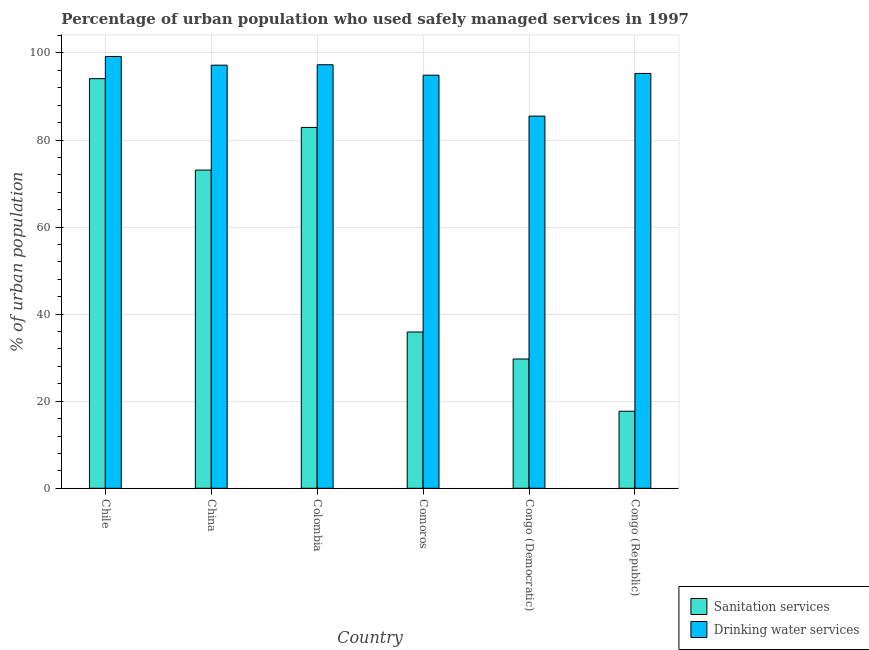How many groups of bars are there?
Offer a terse response. 6. Are the number of bars on each tick of the X-axis equal?
Give a very brief answer. Yes. What is the label of the 5th group of bars from the left?
Give a very brief answer. Congo (Democratic). In how many cases, is the number of bars for a given country not equal to the number of legend labels?
Your response must be concise. 0. What is the percentage of urban population who used drinking water services in Comoros?
Your answer should be very brief. 94.9. Across all countries, what is the maximum percentage of urban population who used drinking water services?
Your answer should be compact. 99.2. Across all countries, what is the minimum percentage of urban population who used drinking water services?
Provide a short and direct response. 85.5. In which country was the percentage of urban population who used sanitation services minimum?
Keep it short and to the point. Congo (Republic). What is the total percentage of urban population who used sanitation services in the graph?
Offer a terse response. 333.4. What is the difference between the percentage of urban population who used drinking water services in China and that in Comoros?
Give a very brief answer. 2.3. What is the difference between the percentage of urban population who used sanitation services in China and the percentage of urban population who used drinking water services in Chile?
Offer a very short reply. -26.1. What is the average percentage of urban population who used drinking water services per country?
Provide a succinct answer. 94.9. What is the difference between the percentage of urban population who used drinking water services and percentage of urban population who used sanitation services in Comoros?
Your answer should be very brief. 59. In how many countries, is the percentage of urban population who used sanitation services greater than 80 %?
Your response must be concise. 2. What is the ratio of the percentage of urban population who used sanitation services in Colombia to that in Congo (Republic)?
Offer a terse response. 4.68. Is the percentage of urban population who used drinking water services in Colombia less than that in Comoros?
Your response must be concise. No. What is the difference between the highest and the second highest percentage of urban population who used sanitation services?
Your answer should be compact. 11.2. What is the difference between the highest and the lowest percentage of urban population who used drinking water services?
Ensure brevity in your answer.  13.7. What does the 2nd bar from the left in Comoros represents?
Your response must be concise. Drinking water services. What does the 1st bar from the right in Comoros represents?
Offer a very short reply. Drinking water services. How many countries are there in the graph?
Your answer should be very brief. 6. What is the difference between two consecutive major ticks on the Y-axis?
Offer a terse response. 20. Are the values on the major ticks of Y-axis written in scientific E-notation?
Provide a succinct answer. No. How many legend labels are there?
Ensure brevity in your answer.  2. How are the legend labels stacked?
Ensure brevity in your answer.  Vertical. What is the title of the graph?
Your response must be concise. Percentage of urban population who used safely managed services in 1997. Does "Electricity and heat production" appear as one of the legend labels in the graph?
Keep it short and to the point. No. What is the label or title of the Y-axis?
Keep it short and to the point. % of urban population. What is the % of urban population in Sanitation services in Chile?
Your response must be concise. 94.1. What is the % of urban population in Drinking water services in Chile?
Your answer should be compact. 99.2. What is the % of urban population in Sanitation services in China?
Offer a very short reply. 73.1. What is the % of urban population of Drinking water services in China?
Your answer should be compact. 97.2. What is the % of urban population in Sanitation services in Colombia?
Keep it short and to the point. 82.9. What is the % of urban population of Drinking water services in Colombia?
Offer a very short reply. 97.3. What is the % of urban population of Sanitation services in Comoros?
Ensure brevity in your answer.  35.9. What is the % of urban population in Drinking water services in Comoros?
Offer a terse response. 94.9. What is the % of urban population of Sanitation services in Congo (Democratic)?
Ensure brevity in your answer.  29.7. What is the % of urban population in Drinking water services in Congo (Democratic)?
Offer a very short reply. 85.5. What is the % of urban population of Sanitation services in Congo (Republic)?
Offer a terse response. 17.7. What is the % of urban population in Drinking water services in Congo (Republic)?
Offer a very short reply. 95.3. Across all countries, what is the maximum % of urban population of Sanitation services?
Ensure brevity in your answer.  94.1. Across all countries, what is the maximum % of urban population in Drinking water services?
Give a very brief answer. 99.2. Across all countries, what is the minimum % of urban population of Sanitation services?
Keep it short and to the point. 17.7. Across all countries, what is the minimum % of urban population of Drinking water services?
Make the answer very short. 85.5. What is the total % of urban population in Sanitation services in the graph?
Give a very brief answer. 333.4. What is the total % of urban population of Drinking water services in the graph?
Provide a short and direct response. 569.4. What is the difference between the % of urban population in Sanitation services in Chile and that in China?
Offer a terse response. 21. What is the difference between the % of urban population in Drinking water services in Chile and that in China?
Ensure brevity in your answer.  2. What is the difference between the % of urban population in Sanitation services in Chile and that in Comoros?
Ensure brevity in your answer.  58.2. What is the difference between the % of urban population of Drinking water services in Chile and that in Comoros?
Your answer should be very brief. 4.3. What is the difference between the % of urban population of Sanitation services in Chile and that in Congo (Democratic)?
Give a very brief answer. 64.4. What is the difference between the % of urban population of Sanitation services in Chile and that in Congo (Republic)?
Give a very brief answer. 76.4. What is the difference between the % of urban population of Drinking water services in China and that in Colombia?
Your response must be concise. -0.1. What is the difference between the % of urban population of Sanitation services in China and that in Comoros?
Ensure brevity in your answer.  37.2. What is the difference between the % of urban population in Sanitation services in China and that in Congo (Democratic)?
Your answer should be compact. 43.4. What is the difference between the % of urban population in Drinking water services in China and that in Congo (Democratic)?
Your answer should be very brief. 11.7. What is the difference between the % of urban population in Sanitation services in China and that in Congo (Republic)?
Make the answer very short. 55.4. What is the difference between the % of urban population in Sanitation services in Colombia and that in Congo (Democratic)?
Your answer should be compact. 53.2. What is the difference between the % of urban population in Drinking water services in Colombia and that in Congo (Democratic)?
Provide a short and direct response. 11.8. What is the difference between the % of urban population in Sanitation services in Colombia and that in Congo (Republic)?
Offer a very short reply. 65.2. What is the difference between the % of urban population in Drinking water services in Colombia and that in Congo (Republic)?
Provide a short and direct response. 2. What is the difference between the % of urban population of Sanitation services in Comoros and that in Congo (Democratic)?
Your answer should be compact. 6.2. What is the difference between the % of urban population in Drinking water services in Comoros and that in Congo (Democratic)?
Offer a very short reply. 9.4. What is the difference between the % of urban population in Drinking water services in Comoros and that in Congo (Republic)?
Provide a succinct answer. -0.4. What is the difference between the % of urban population of Sanitation services in Chile and the % of urban population of Drinking water services in Comoros?
Provide a short and direct response. -0.8. What is the difference between the % of urban population in Sanitation services in Chile and the % of urban population in Drinking water services in Congo (Democratic)?
Provide a succinct answer. 8.6. What is the difference between the % of urban population in Sanitation services in Chile and the % of urban population in Drinking water services in Congo (Republic)?
Keep it short and to the point. -1.2. What is the difference between the % of urban population in Sanitation services in China and the % of urban population in Drinking water services in Colombia?
Provide a succinct answer. -24.2. What is the difference between the % of urban population of Sanitation services in China and the % of urban population of Drinking water services in Comoros?
Offer a very short reply. -21.8. What is the difference between the % of urban population of Sanitation services in China and the % of urban population of Drinking water services in Congo (Democratic)?
Your answer should be compact. -12.4. What is the difference between the % of urban population of Sanitation services in China and the % of urban population of Drinking water services in Congo (Republic)?
Give a very brief answer. -22.2. What is the difference between the % of urban population in Sanitation services in Colombia and the % of urban population in Drinking water services in Comoros?
Provide a succinct answer. -12. What is the difference between the % of urban population in Sanitation services in Colombia and the % of urban population in Drinking water services in Congo (Democratic)?
Ensure brevity in your answer.  -2.6. What is the difference between the % of urban population of Sanitation services in Comoros and the % of urban population of Drinking water services in Congo (Democratic)?
Give a very brief answer. -49.6. What is the difference between the % of urban population of Sanitation services in Comoros and the % of urban population of Drinking water services in Congo (Republic)?
Offer a terse response. -59.4. What is the difference between the % of urban population of Sanitation services in Congo (Democratic) and the % of urban population of Drinking water services in Congo (Republic)?
Keep it short and to the point. -65.6. What is the average % of urban population of Sanitation services per country?
Your response must be concise. 55.57. What is the average % of urban population of Drinking water services per country?
Your response must be concise. 94.9. What is the difference between the % of urban population of Sanitation services and % of urban population of Drinking water services in Chile?
Offer a terse response. -5.1. What is the difference between the % of urban population in Sanitation services and % of urban population in Drinking water services in China?
Offer a terse response. -24.1. What is the difference between the % of urban population in Sanitation services and % of urban population in Drinking water services in Colombia?
Provide a succinct answer. -14.4. What is the difference between the % of urban population of Sanitation services and % of urban population of Drinking water services in Comoros?
Offer a terse response. -59. What is the difference between the % of urban population in Sanitation services and % of urban population in Drinking water services in Congo (Democratic)?
Your response must be concise. -55.8. What is the difference between the % of urban population in Sanitation services and % of urban population in Drinking water services in Congo (Republic)?
Offer a terse response. -77.6. What is the ratio of the % of urban population in Sanitation services in Chile to that in China?
Your response must be concise. 1.29. What is the ratio of the % of urban population of Drinking water services in Chile to that in China?
Provide a succinct answer. 1.02. What is the ratio of the % of urban population of Sanitation services in Chile to that in Colombia?
Offer a terse response. 1.14. What is the ratio of the % of urban population of Drinking water services in Chile to that in Colombia?
Offer a very short reply. 1.02. What is the ratio of the % of urban population of Sanitation services in Chile to that in Comoros?
Provide a short and direct response. 2.62. What is the ratio of the % of urban population of Drinking water services in Chile to that in Comoros?
Offer a terse response. 1.05. What is the ratio of the % of urban population in Sanitation services in Chile to that in Congo (Democratic)?
Give a very brief answer. 3.17. What is the ratio of the % of urban population of Drinking water services in Chile to that in Congo (Democratic)?
Your answer should be very brief. 1.16. What is the ratio of the % of urban population in Sanitation services in Chile to that in Congo (Republic)?
Your response must be concise. 5.32. What is the ratio of the % of urban population of Drinking water services in Chile to that in Congo (Republic)?
Keep it short and to the point. 1.04. What is the ratio of the % of urban population of Sanitation services in China to that in Colombia?
Offer a very short reply. 0.88. What is the ratio of the % of urban population of Drinking water services in China to that in Colombia?
Your response must be concise. 1. What is the ratio of the % of urban population in Sanitation services in China to that in Comoros?
Your answer should be very brief. 2.04. What is the ratio of the % of urban population of Drinking water services in China to that in Comoros?
Give a very brief answer. 1.02. What is the ratio of the % of urban population of Sanitation services in China to that in Congo (Democratic)?
Provide a short and direct response. 2.46. What is the ratio of the % of urban population of Drinking water services in China to that in Congo (Democratic)?
Offer a terse response. 1.14. What is the ratio of the % of urban population of Sanitation services in China to that in Congo (Republic)?
Provide a succinct answer. 4.13. What is the ratio of the % of urban population of Drinking water services in China to that in Congo (Republic)?
Keep it short and to the point. 1.02. What is the ratio of the % of urban population of Sanitation services in Colombia to that in Comoros?
Make the answer very short. 2.31. What is the ratio of the % of urban population of Drinking water services in Colombia to that in Comoros?
Keep it short and to the point. 1.03. What is the ratio of the % of urban population in Sanitation services in Colombia to that in Congo (Democratic)?
Your answer should be compact. 2.79. What is the ratio of the % of urban population in Drinking water services in Colombia to that in Congo (Democratic)?
Make the answer very short. 1.14. What is the ratio of the % of urban population in Sanitation services in Colombia to that in Congo (Republic)?
Make the answer very short. 4.68. What is the ratio of the % of urban population in Drinking water services in Colombia to that in Congo (Republic)?
Your answer should be compact. 1.02. What is the ratio of the % of urban population in Sanitation services in Comoros to that in Congo (Democratic)?
Offer a very short reply. 1.21. What is the ratio of the % of urban population of Drinking water services in Comoros to that in Congo (Democratic)?
Give a very brief answer. 1.11. What is the ratio of the % of urban population in Sanitation services in Comoros to that in Congo (Republic)?
Ensure brevity in your answer.  2.03. What is the ratio of the % of urban population in Drinking water services in Comoros to that in Congo (Republic)?
Your answer should be very brief. 1. What is the ratio of the % of urban population in Sanitation services in Congo (Democratic) to that in Congo (Republic)?
Offer a very short reply. 1.68. What is the ratio of the % of urban population of Drinking water services in Congo (Democratic) to that in Congo (Republic)?
Keep it short and to the point. 0.9. What is the difference between the highest and the second highest % of urban population in Sanitation services?
Ensure brevity in your answer.  11.2. What is the difference between the highest and the lowest % of urban population in Sanitation services?
Provide a succinct answer. 76.4. What is the difference between the highest and the lowest % of urban population of Drinking water services?
Your answer should be compact. 13.7. 